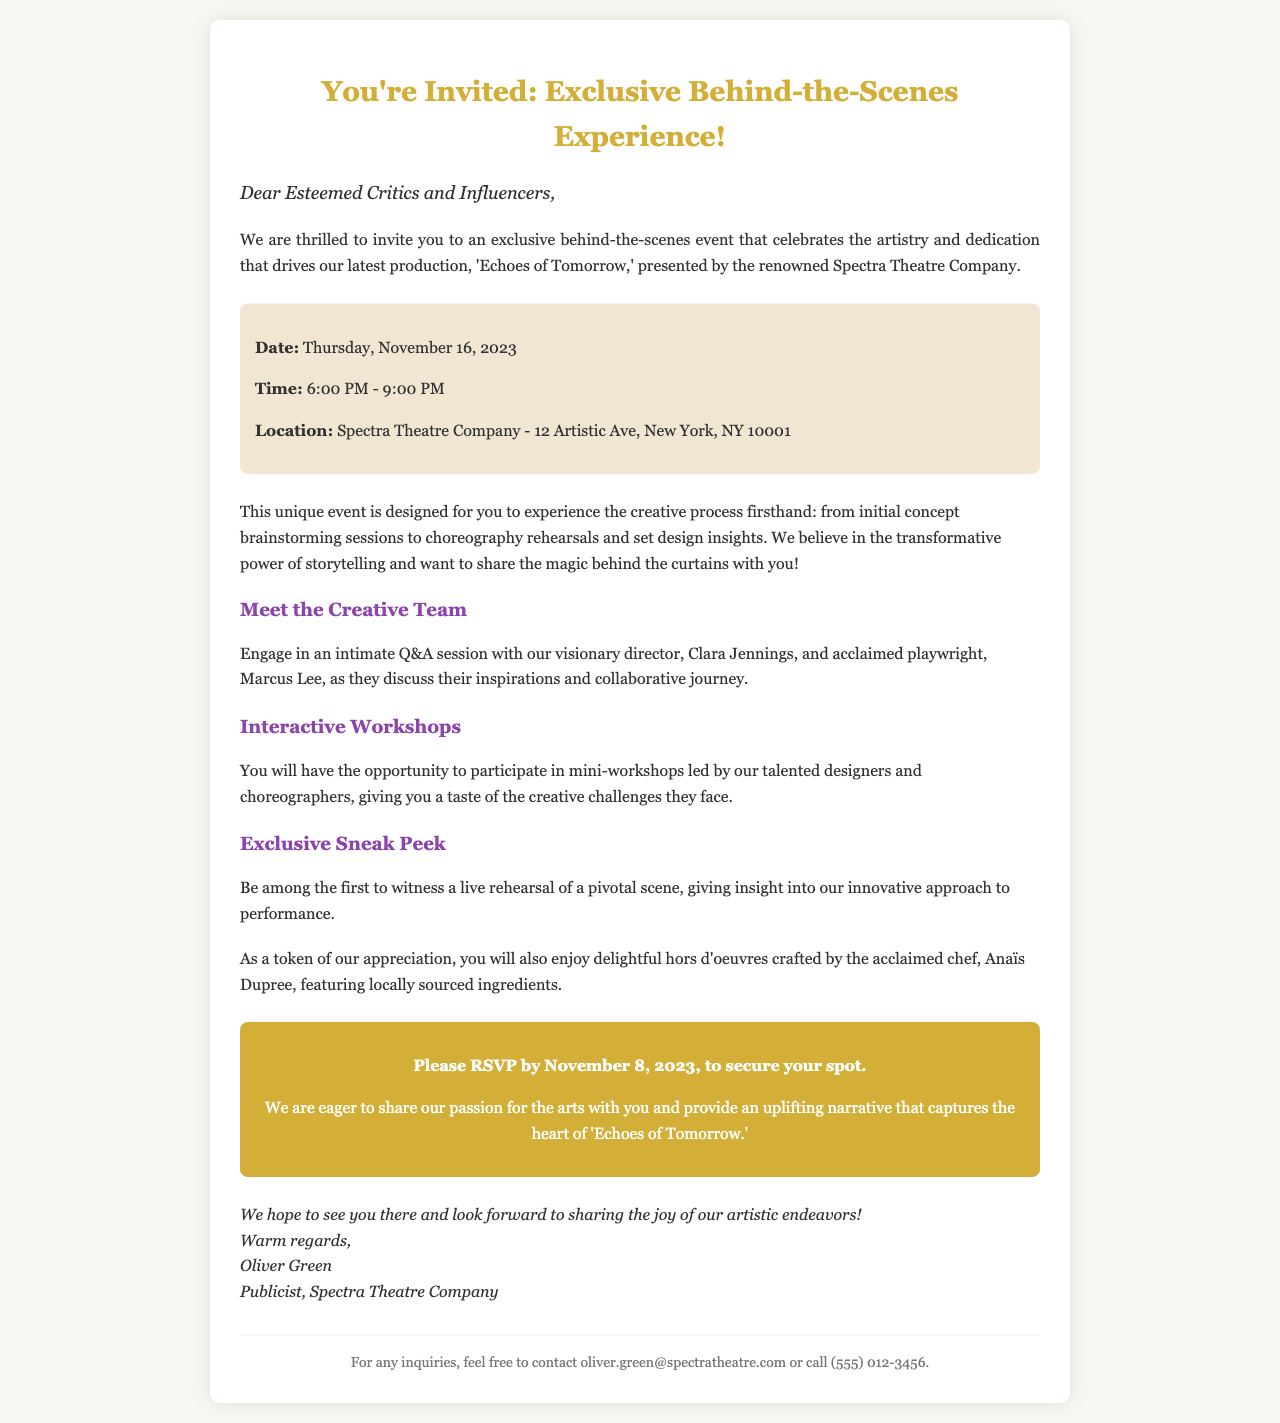What is the date of the event? The date of the event is explicitly stated in the document.
Answer: Thursday, November 16, 2023 What time does the event start? The start time is highlighted in the event details section.
Answer: 6:00 PM Who is the director mentioned in the email? The director's name is provided as part of the creative team introduction.
Answer: Clara Jennings What type of food will be served at the event? The document mentions the type of culinary offerings available during the event.
Answer: hors d'oeuvres By what date should attendees RSVP? The RSVP deadline is clearly indicated in the call-to-action section of the document.
Answer: November 8, 2023 What will attendees participate in during the event? It describes the activities planned for attendees, requiring synthesis of information from the document.
Answer: Interactive Workshops What is the name of the production being showcased? The title of the production is mentioned in the introduction.
Answer: Echoes of Tomorrow How many hours will the event last? The duration of the event can be calculated from the starting and ending times.
Answer: 3 hours 